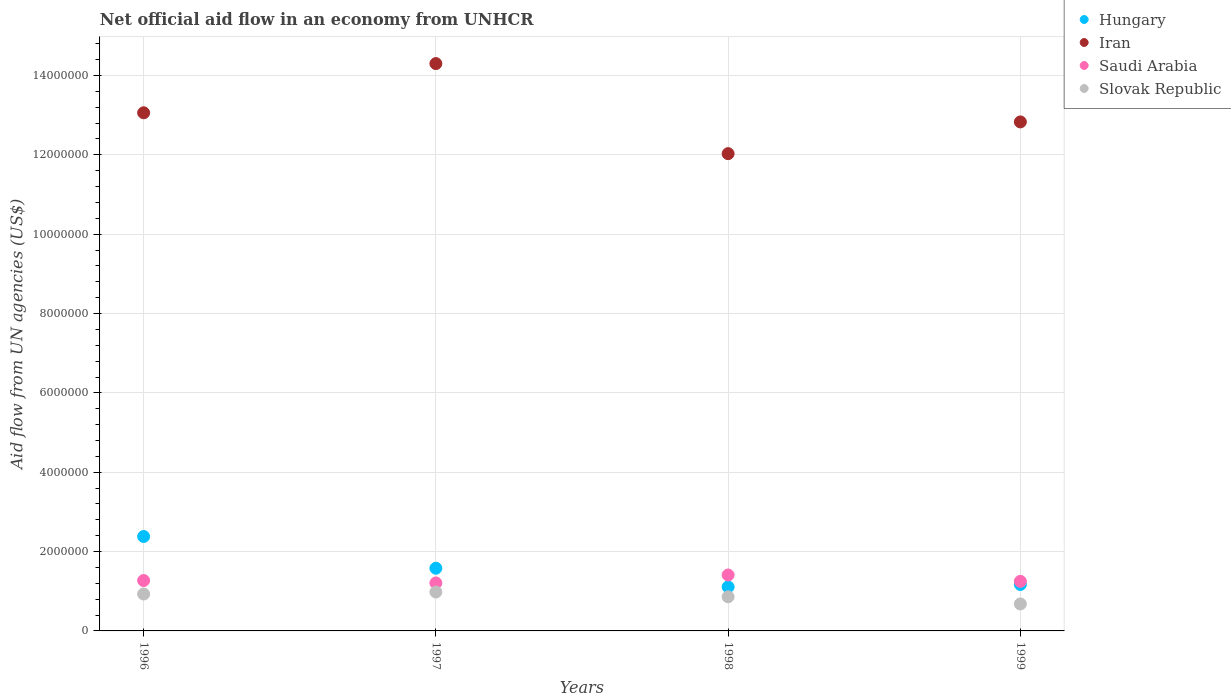What is the net official aid flow in Saudi Arabia in 1998?
Offer a very short reply. 1.41e+06. Across all years, what is the maximum net official aid flow in Hungary?
Make the answer very short. 2.38e+06. Across all years, what is the minimum net official aid flow in Hungary?
Make the answer very short. 1.11e+06. In which year was the net official aid flow in Saudi Arabia maximum?
Your response must be concise. 1998. What is the total net official aid flow in Slovak Republic in the graph?
Offer a terse response. 3.45e+06. What is the difference between the net official aid flow in Slovak Republic in 1997 and that in 1998?
Your answer should be very brief. 1.20e+05. What is the difference between the net official aid flow in Slovak Republic in 1997 and the net official aid flow in Iran in 1996?
Your answer should be very brief. -1.21e+07. What is the average net official aid flow in Hungary per year?
Provide a succinct answer. 1.56e+06. In the year 1996, what is the difference between the net official aid flow in Saudi Arabia and net official aid flow in Iran?
Give a very brief answer. -1.18e+07. In how many years, is the net official aid flow in Saudi Arabia greater than 11600000 US$?
Offer a terse response. 0. What is the ratio of the net official aid flow in Iran in 1998 to that in 1999?
Give a very brief answer. 0.94. Is the difference between the net official aid flow in Saudi Arabia in 1996 and 1997 greater than the difference between the net official aid flow in Iran in 1996 and 1997?
Your response must be concise. Yes. What is the difference between the highest and the second highest net official aid flow in Slovak Republic?
Provide a short and direct response. 5.00e+04. In how many years, is the net official aid flow in Hungary greater than the average net official aid flow in Hungary taken over all years?
Provide a succinct answer. 2. Is the sum of the net official aid flow in Iran in 1997 and 1998 greater than the maximum net official aid flow in Slovak Republic across all years?
Your answer should be very brief. Yes. Does the net official aid flow in Saudi Arabia monotonically increase over the years?
Your answer should be compact. No. Is the net official aid flow in Hungary strictly less than the net official aid flow in Slovak Republic over the years?
Your answer should be compact. No. Does the graph contain grids?
Your response must be concise. Yes. Where does the legend appear in the graph?
Provide a short and direct response. Top right. What is the title of the graph?
Provide a succinct answer. Net official aid flow in an economy from UNHCR. What is the label or title of the X-axis?
Your answer should be very brief. Years. What is the label or title of the Y-axis?
Make the answer very short. Aid flow from UN agencies (US$). What is the Aid flow from UN agencies (US$) of Hungary in 1996?
Give a very brief answer. 2.38e+06. What is the Aid flow from UN agencies (US$) of Iran in 1996?
Ensure brevity in your answer.  1.31e+07. What is the Aid flow from UN agencies (US$) of Saudi Arabia in 1996?
Your answer should be compact. 1.27e+06. What is the Aid flow from UN agencies (US$) in Slovak Republic in 1996?
Provide a short and direct response. 9.30e+05. What is the Aid flow from UN agencies (US$) of Hungary in 1997?
Keep it short and to the point. 1.58e+06. What is the Aid flow from UN agencies (US$) of Iran in 1997?
Offer a very short reply. 1.43e+07. What is the Aid flow from UN agencies (US$) of Saudi Arabia in 1997?
Make the answer very short. 1.21e+06. What is the Aid flow from UN agencies (US$) of Slovak Republic in 1997?
Make the answer very short. 9.80e+05. What is the Aid flow from UN agencies (US$) in Hungary in 1998?
Your answer should be very brief. 1.11e+06. What is the Aid flow from UN agencies (US$) in Iran in 1998?
Provide a succinct answer. 1.20e+07. What is the Aid flow from UN agencies (US$) of Saudi Arabia in 1998?
Ensure brevity in your answer.  1.41e+06. What is the Aid flow from UN agencies (US$) of Slovak Republic in 1998?
Ensure brevity in your answer.  8.60e+05. What is the Aid flow from UN agencies (US$) in Hungary in 1999?
Make the answer very short. 1.17e+06. What is the Aid flow from UN agencies (US$) in Iran in 1999?
Provide a succinct answer. 1.28e+07. What is the Aid flow from UN agencies (US$) of Saudi Arabia in 1999?
Ensure brevity in your answer.  1.25e+06. What is the Aid flow from UN agencies (US$) of Slovak Republic in 1999?
Your response must be concise. 6.80e+05. Across all years, what is the maximum Aid flow from UN agencies (US$) of Hungary?
Make the answer very short. 2.38e+06. Across all years, what is the maximum Aid flow from UN agencies (US$) of Iran?
Your response must be concise. 1.43e+07. Across all years, what is the maximum Aid flow from UN agencies (US$) of Saudi Arabia?
Offer a terse response. 1.41e+06. Across all years, what is the maximum Aid flow from UN agencies (US$) of Slovak Republic?
Provide a succinct answer. 9.80e+05. Across all years, what is the minimum Aid flow from UN agencies (US$) in Hungary?
Your answer should be compact. 1.11e+06. Across all years, what is the minimum Aid flow from UN agencies (US$) in Iran?
Your answer should be very brief. 1.20e+07. Across all years, what is the minimum Aid flow from UN agencies (US$) in Saudi Arabia?
Make the answer very short. 1.21e+06. Across all years, what is the minimum Aid flow from UN agencies (US$) of Slovak Republic?
Provide a short and direct response. 6.80e+05. What is the total Aid flow from UN agencies (US$) of Hungary in the graph?
Make the answer very short. 6.24e+06. What is the total Aid flow from UN agencies (US$) in Iran in the graph?
Make the answer very short. 5.22e+07. What is the total Aid flow from UN agencies (US$) in Saudi Arabia in the graph?
Keep it short and to the point. 5.14e+06. What is the total Aid flow from UN agencies (US$) in Slovak Republic in the graph?
Your response must be concise. 3.45e+06. What is the difference between the Aid flow from UN agencies (US$) in Hungary in 1996 and that in 1997?
Offer a very short reply. 8.00e+05. What is the difference between the Aid flow from UN agencies (US$) in Iran in 1996 and that in 1997?
Make the answer very short. -1.24e+06. What is the difference between the Aid flow from UN agencies (US$) of Hungary in 1996 and that in 1998?
Ensure brevity in your answer.  1.27e+06. What is the difference between the Aid flow from UN agencies (US$) in Iran in 1996 and that in 1998?
Offer a very short reply. 1.03e+06. What is the difference between the Aid flow from UN agencies (US$) of Saudi Arabia in 1996 and that in 1998?
Make the answer very short. -1.40e+05. What is the difference between the Aid flow from UN agencies (US$) in Slovak Republic in 1996 and that in 1998?
Your answer should be compact. 7.00e+04. What is the difference between the Aid flow from UN agencies (US$) of Hungary in 1996 and that in 1999?
Offer a very short reply. 1.21e+06. What is the difference between the Aid flow from UN agencies (US$) of Iran in 1996 and that in 1999?
Offer a terse response. 2.30e+05. What is the difference between the Aid flow from UN agencies (US$) of Slovak Republic in 1996 and that in 1999?
Offer a very short reply. 2.50e+05. What is the difference between the Aid flow from UN agencies (US$) in Hungary in 1997 and that in 1998?
Make the answer very short. 4.70e+05. What is the difference between the Aid flow from UN agencies (US$) in Iran in 1997 and that in 1998?
Give a very brief answer. 2.27e+06. What is the difference between the Aid flow from UN agencies (US$) in Slovak Republic in 1997 and that in 1998?
Your answer should be very brief. 1.20e+05. What is the difference between the Aid flow from UN agencies (US$) of Iran in 1997 and that in 1999?
Give a very brief answer. 1.47e+06. What is the difference between the Aid flow from UN agencies (US$) in Hungary in 1998 and that in 1999?
Give a very brief answer. -6.00e+04. What is the difference between the Aid flow from UN agencies (US$) in Iran in 1998 and that in 1999?
Keep it short and to the point. -8.00e+05. What is the difference between the Aid flow from UN agencies (US$) of Hungary in 1996 and the Aid flow from UN agencies (US$) of Iran in 1997?
Your answer should be very brief. -1.19e+07. What is the difference between the Aid flow from UN agencies (US$) of Hungary in 1996 and the Aid flow from UN agencies (US$) of Saudi Arabia in 1997?
Keep it short and to the point. 1.17e+06. What is the difference between the Aid flow from UN agencies (US$) of Hungary in 1996 and the Aid flow from UN agencies (US$) of Slovak Republic in 1997?
Ensure brevity in your answer.  1.40e+06. What is the difference between the Aid flow from UN agencies (US$) of Iran in 1996 and the Aid flow from UN agencies (US$) of Saudi Arabia in 1997?
Make the answer very short. 1.18e+07. What is the difference between the Aid flow from UN agencies (US$) in Iran in 1996 and the Aid flow from UN agencies (US$) in Slovak Republic in 1997?
Provide a short and direct response. 1.21e+07. What is the difference between the Aid flow from UN agencies (US$) in Hungary in 1996 and the Aid flow from UN agencies (US$) in Iran in 1998?
Offer a terse response. -9.65e+06. What is the difference between the Aid flow from UN agencies (US$) in Hungary in 1996 and the Aid flow from UN agencies (US$) in Saudi Arabia in 1998?
Your answer should be very brief. 9.70e+05. What is the difference between the Aid flow from UN agencies (US$) in Hungary in 1996 and the Aid flow from UN agencies (US$) in Slovak Republic in 1998?
Provide a succinct answer. 1.52e+06. What is the difference between the Aid flow from UN agencies (US$) in Iran in 1996 and the Aid flow from UN agencies (US$) in Saudi Arabia in 1998?
Offer a very short reply. 1.16e+07. What is the difference between the Aid flow from UN agencies (US$) in Iran in 1996 and the Aid flow from UN agencies (US$) in Slovak Republic in 1998?
Your answer should be compact. 1.22e+07. What is the difference between the Aid flow from UN agencies (US$) of Saudi Arabia in 1996 and the Aid flow from UN agencies (US$) of Slovak Republic in 1998?
Offer a very short reply. 4.10e+05. What is the difference between the Aid flow from UN agencies (US$) in Hungary in 1996 and the Aid flow from UN agencies (US$) in Iran in 1999?
Provide a short and direct response. -1.04e+07. What is the difference between the Aid flow from UN agencies (US$) in Hungary in 1996 and the Aid flow from UN agencies (US$) in Saudi Arabia in 1999?
Your answer should be very brief. 1.13e+06. What is the difference between the Aid flow from UN agencies (US$) of Hungary in 1996 and the Aid flow from UN agencies (US$) of Slovak Republic in 1999?
Keep it short and to the point. 1.70e+06. What is the difference between the Aid flow from UN agencies (US$) of Iran in 1996 and the Aid flow from UN agencies (US$) of Saudi Arabia in 1999?
Your answer should be compact. 1.18e+07. What is the difference between the Aid flow from UN agencies (US$) of Iran in 1996 and the Aid flow from UN agencies (US$) of Slovak Republic in 1999?
Make the answer very short. 1.24e+07. What is the difference between the Aid flow from UN agencies (US$) in Saudi Arabia in 1996 and the Aid flow from UN agencies (US$) in Slovak Republic in 1999?
Provide a short and direct response. 5.90e+05. What is the difference between the Aid flow from UN agencies (US$) in Hungary in 1997 and the Aid flow from UN agencies (US$) in Iran in 1998?
Provide a succinct answer. -1.04e+07. What is the difference between the Aid flow from UN agencies (US$) of Hungary in 1997 and the Aid flow from UN agencies (US$) of Saudi Arabia in 1998?
Your answer should be compact. 1.70e+05. What is the difference between the Aid flow from UN agencies (US$) in Hungary in 1997 and the Aid flow from UN agencies (US$) in Slovak Republic in 1998?
Make the answer very short. 7.20e+05. What is the difference between the Aid flow from UN agencies (US$) in Iran in 1997 and the Aid flow from UN agencies (US$) in Saudi Arabia in 1998?
Provide a short and direct response. 1.29e+07. What is the difference between the Aid flow from UN agencies (US$) of Iran in 1997 and the Aid flow from UN agencies (US$) of Slovak Republic in 1998?
Your response must be concise. 1.34e+07. What is the difference between the Aid flow from UN agencies (US$) in Saudi Arabia in 1997 and the Aid flow from UN agencies (US$) in Slovak Republic in 1998?
Provide a succinct answer. 3.50e+05. What is the difference between the Aid flow from UN agencies (US$) of Hungary in 1997 and the Aid flow from UN agencies (US$) of Iran in 1999?
Your response must be concise. -1.12e+07. What is the difference between the Aid flow from UN agencies (US$) in Hungary in 1997 and the Aid flow from UN agencies (US$) in Slovak Republic in 1999?
Keep it short and to the point. 9.00e+05. What is the difference between the Aid flow from UN agencies (US$) in Iran in 1997 and the Aid flow from UN agencies (US$) in Saudi Arabia in 1999?
Offer a very short reply. 1.30e+07. What is the difference between the Aid flow from UN agencies (US$) of Iran in 1997 and the Aid flow from UN agencies (US$) of Slovak Republic in 1999?
Offer a very short reply. 1.36e+07. What is the difference between the Aid flow from UN agencies (US$) in Saudi Arabia in 1997 and the Aid flow from UN agencies (US$) in Slovak Republic in 1999?
Your answer should be very brief. 5.30e+05. What is the difference between the Aid flow from UN agencies (US$) in Hungary in 1998 and the Aid flow from UN agencies (US$) in Iran in 1999?
Offer a terse response. -1.17e+07. What is the difference between the Aid flow from UN agencies (US$) in Hungary in 1998 and the Aid flow from UN agencies (US$) in Saudi Arabia in 1999?
Make the answer very short. -1.40e+05. What is the difference between the Aid flow from UN agencies (US$) in Hungary in 1998 and the Aid flow from UN agencies (US$) in Slovak Republic in 1999?
Offer a very short reply. 4.30e+05. What is the difference between the Aid flow from UN agencies (US$) of Iran in 1998 and the Aid flow from UN agencies (US$) of Saudi Arabia in 1999?
Ensure brevity in your answer.  1.08e+07. What is the difference between the Aid flow from UN agencies (US$) of Iran in 1998 and the Aid flow from UN agencies (US$) of Slovak Republic in 1999?
Offer a very short reply. 1.14e+07. What is the difference between the Aid flow from UN agencies (US$) in Saudi Arabia in 1998 and the Aid flow from UN agencies (US$) in Slovak Republic in 1999?
Offer a very short reply. 7.30e+05. What is the average Aid flow from UN agencies (US$) in Hungary per year?
Your response must be concise. 1.56e+06. What is the average Aid flow from UN agencies (US$) of Iran per year?
Ensure brevity in your answer.  1.31e+07. What is the average Aid flow from UN agencies (US$) of Saudi Arabia per year?
Ensure brevity in your answer.  1.28e+06. What is the average Aid flow from UN agencies (US$) of Slovak Republic per year?
Give a very brief answer. 8.62e+05. In the year 1996, what is the difference between the Aid flow from UN agencies (US$) in Hungary and Aid flow from UN agencies (US$) in Iran?
Ensure brevity in your answer.  -1.07e+07. In the year 1996, what is the difference between the Aid flow from UN agencies (US$) in Hungary and Aid flow from UN agencies (US$) in Saudi Arabia?
Provide a short and direct response. 1.11e+06. In the year 1996, what is the difference between the Aid flow from UN agencies (US$) of Hungary and Aid flow from UN agencies (US$) of Slovak Republic?
Keep it short and to the point. 1.45e+06. In the year 1996, what is the difference between the Aid flow from UN agencies (US$) in Iran and Aid flow from UN agencies (US$) in Saudi Arabia?
Offer a terse response. 1.18e+07. In the year 1996, what is the difference between the Aid flow from UN agencies (US$) in Iran and Aid flow from UN agencies (US$) in Slovak Republic?
Ensure brevity in your answer.  1.21e+07. In the year 1997, what is the difference between the Aid flow from UN agencies (US$) of Hungary and Aid flow from UN agencies (US$) of Iran?
Your answer should be very brief. -1.27e+07. In the year 1997, what is the difference between the Aid flow from UN agencies (US$) of Hungary and Aid flow from UN agencies (US$) of Saudi Arabia?
Offer a terse response. 3.70e+05. In the year 1997, what is the difference between the Aid flow from UN agencies (US$) in Iran and Aid flow from UN agencies (US$) in Saudi Arabia?
Provide a short and direct response. 1.31e+07. In the year 1997, what is the difference between the Aid flow from UN agencies (US$) of Iran and Aid flow from UN agencies (US$) of Slovak Republic?
Offer a very short reply. 1.33e+07. In the year 1997, what is the difference between the Aid flow from UN agencies (US$) in Saudi Arabia and Aid flow from UN agencies (US$) in Slovak Republic?
Provide a succinct answer. 2.30e+05. In the year 1998, what is the difference between the Aid flow from UN agencies (US$) of Hungary and Aid flow from UN agencies (US$) of Iran?
Offer a very short reply. -1.09e+07. In the year 1998, what is the difference between the Aid flow from UN agencies (US$) of Hungary and Aid flow from UN agencies (US$) of Slovak Republic?
Make the answer very short. 2.50e+05. In the year 1998, what is the difference between the Aid flow from UN agencies (US$) of Iran and Aid flow from UN agencies (US$) of Saudi Arabia?
Offer a very short reply. 1.06e+07. In the year 1998, what is the difference between the Aid flow from UN agencies (US$) in Iran and Aid flow from UN agencies (US$) in Slovak Republic?
Keep it short and to the point. 1.12e+07. In the year 1999, what is the difference between the Aid flow from UN agencies (US$) in Hungary and Aid flow from UN agencies (US$) in Iran?
Ensure brevity in your answer.  -1.17e+07. In the year 1999, what is the difference between the Aid flow from UN agencies (US$) of Hungary and Aid flow from UN agencies (US$) of Slovak Republic?
Offer a terse response. 4.90e+05. In the year 1999, what is the difference between the Aid flow from UN agencies (US$) in Iran and Aid flow from UN agencies (US$) in Saudi Arabia?
Provide a succinct answer. 1.16e+07. In the year 1999, what is the difference between the Aid flow from UN agencies (US$) of Iran and Aid flow from UN agencies (US$) of Slovak Republic?
Give a very brief answer. 1.22e+07. In the year 1999, what is the difference between the Aid flow from UN agencies (US$) in Saudi Arabia and Aid flow from UN agencies (US$) in Slovak Republic?
Offer a terse response. 5.70e+05. What is the ratio of the Aid flow from UN agencies (US$) of Hungary in 1996 to that in 1997?
Offer a terse response. 1.51. What is the ratio of the Aid flow from UN agencies (US$) in Iran in 1996 to that in 1997?
Make the answer very short. 0.91. What is the ratio of the Aid flow from UN agencies (US$) in Saudi Arabia in 1996 to that in 1997?
Keep it short and to the point. 1.05. What is the ratio of the Aid flow from UN agencies (US$) in Slovak Republic in 1996 to that in 1997?
Offer a very short reply. 0.95. What is the ratio of the Aid flow from UN agencies (US$) in Hungary in 1996 to that in 1998?
Provide a succinct answer. 2.14. What is the ratio of the Aid flow from UN agencies (US$) of Iran in 1996 to that in 1998?
Your answer should be very brief. 1.09. What is the ratio of the Aid flow from UN agencies (US$) in Saudi Arabia in 1996 to that in 1998?
Offer a terse response. 0.9. What is the ratio of the Aid flow from UN agencies (US$) in Slovak Republic in 1996 to that in 1998?
Give a very brief answer. 1.08. What is the ratio of the Aid flow from UN agencies (US$) in Hungary in 1996 to that in 1999?
Give a very brief answer. 2.03. What is the ratio of the Aid flow from UN agencies (US$) in Iran in 1996 to that in 1999?
Give a very brief answer. 1.02. What is the ratio of the Aid flow from UN agencies (US$) of Slovak Republic in 1996 to that in 1999?
Offer a terse response. 1.37. What is the ratio of the Aid flow from UN agencies (US$) in Hungary in 1997 to that in 1998?
Your answer should be compact. 1.42. What is the ratio of the Aid flow from UN agencies (US$) in Iran in 1997 to that in 1998?
Keep it short and to the point. 1.19. What is the ratio of the Aid flow from UN agencies (US$) of Saudi Arabia in 1997 to that in 1998?
Keep it short and to the point. 0.86. What is the ratio of the Aid flow from UN agencies (US$) of Slovak Republic in 1997 to that in 1998?
Offer a very short reply. 1.14. What is the ratio of the Aid flow from UN agencies (US$) in Hungary in 1997 to that in 1999?
Your answer should be compact. 1.35. What is the ratio of the Aid flow from UN agencies (US$) in Iran in 1997 to that in 1999?
Make the answer very short. 1.11. What is the ratio of the Aid flow from UN agencies (US$) in Slovak Republic in 1997 to that in 1999?
Provide a short and direct response. 1.44. What is the ratio of the Aid flow from UN agencies (US$) of Hungary in 1998 to that in 1999?
Give a very brief answer. 0.95. What is the ratio of the Aid flow from UN agencies (US$) in Iran in 1998 to that in 1999?
Ensure brevity in your answer.  0.94. What is the ratio of the Aid flow from UN agencies (US$) of Saudi Arabia in 1998 to that in 1999?
Your answer should be very brief. 1.13. What is the ratio of the Aid flow from UN agencies (US$) of Slovak Republic in 1998 to that in 1999?
Offer a terse response. 1.26. What is the difference between the highest and the second highest Aid flow from UN agencies (US$) of Iran?
Your answer should be compact. 1.24e+06. What is the difference between the highest and the second highest Aid flow from UN agencies (US$) in Saudi Arabia?
Provide a succinct answer. 1.40e+05. What is the difference between the highest and the lowest Aid flow from UN agencies (US$) of Hungary?
Ensure brevity in your answer.  1.27e+06. What is the difference between the highest and the lowest Aid flow from UN agencies (US$) of Iran?
Provide a succinct answer. 2.27e+06. What is the difference between the highest and the lowest Aid flow from UN agencies (US$) in Saudi Arabia?
Your answer should be very brief. 2.00e+05. 